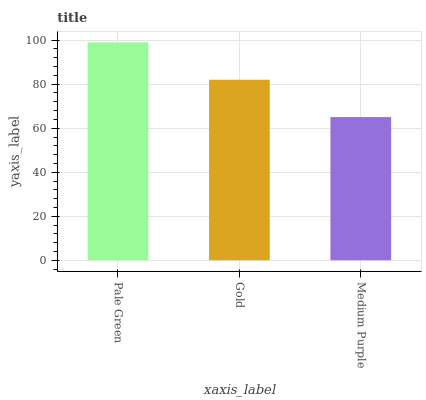Is Gold the minimum?
Answer yes or no. No. Is Gold the maximum?
Answer yes or no. No. Is Pale Green greater than Gold?
Answer yes or no. Yes. Is Gold less than Pale Green?
Answer yes or no. Yes. Is Gold greater than Pale Green?
Answer yes or no. No. Is Pale Green less than Gold?
Answer yes or no. No. Is Gold the high median?
Answer yes or no. Yes. Is Gold the low median?
Answer yes or no. Yes. Is Pale Green the high median?
Answer yes or no. No. Is Medium Purple the low median?
Answer yes or no. No. 